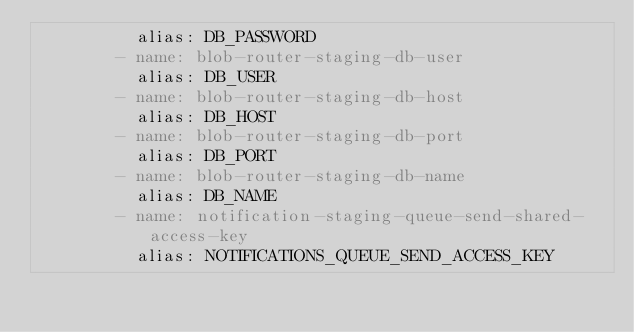<code> <loc_0><loc_0><loc_500><loc_500><_YAML_>          alias: DB_PASSWORD
        - name: blob-router-staging-db-user
          alias: DB_USER
        - name: blob-router-staging-db-host
          alias: DB_HOST
        - name: blob-router-staging-db-port
          alias: DB_PORT
        - name: blob-router-staging-db-name
          alias: DB_NAME
        - name: notification-staging-queue-send-shared-access-key
          alias: NOTIFICATIONS_QUEUE_SEND_ACCESS_KEY
</code> 